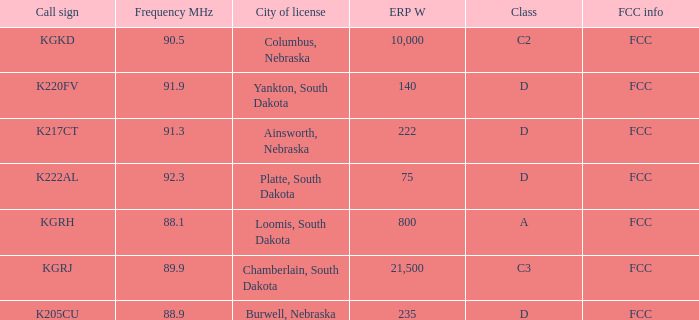What is the sum of the erp w of the k222al call sign? 75.0. 